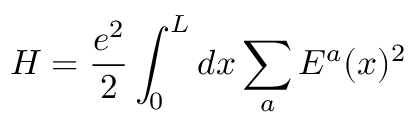<formula> <loc_0><loc_0><loc_500><loc_500>H = \frac { e ^ { 2 } } { 2 } \int _ { 0 } ^ { L } d x \sum _ { a } E ^ { a } ( x ) ^ { 2 }</formula> 